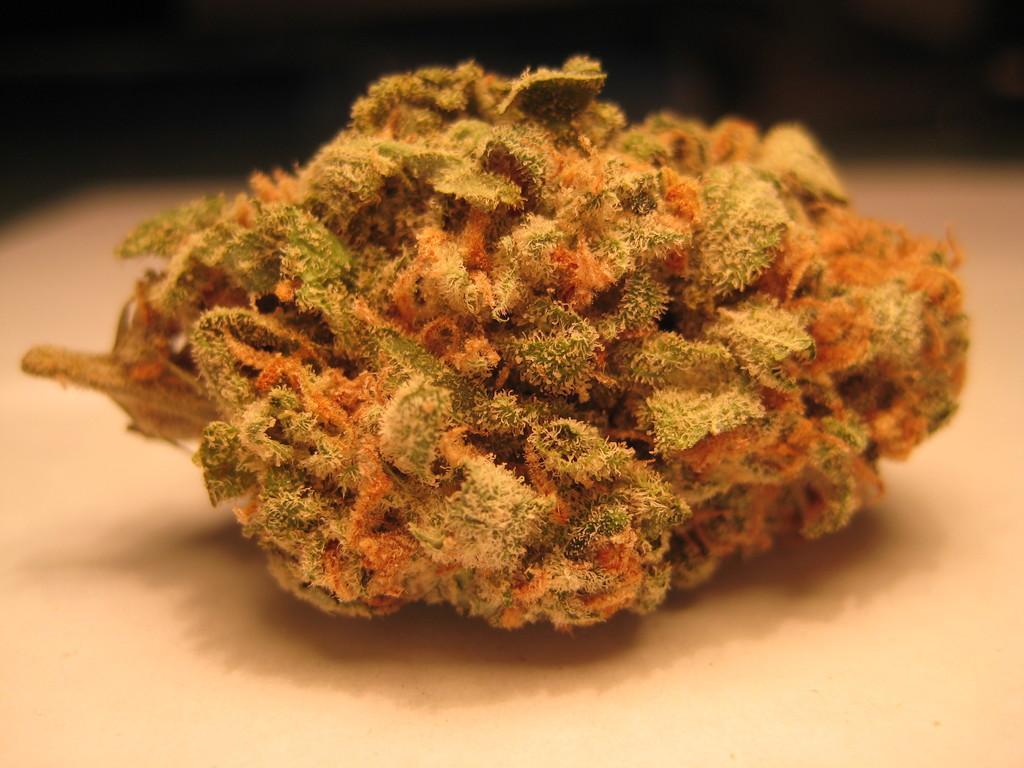Describe this image in one or two sentences. In the picture we can see some different thing which is in green, red and brown in color. 